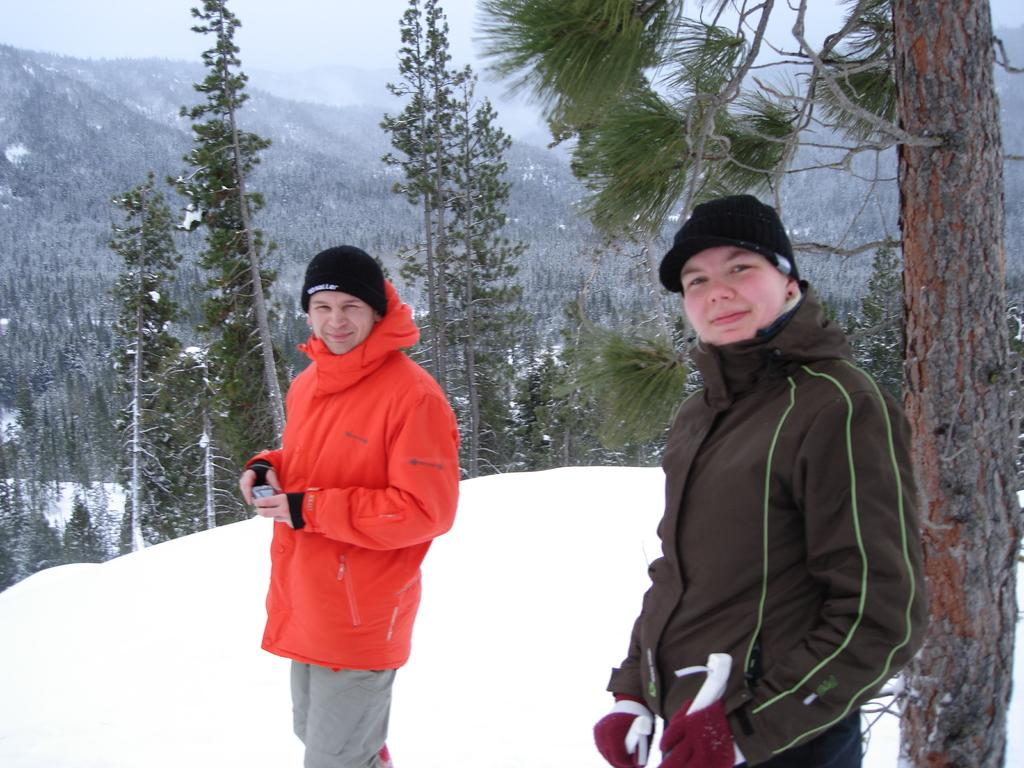What can be seen in the image regarding the people present? There are men standing in the image. What are the men wearing that might provide information about the weather or season? The men are wearing jackets. What type of terrain is visible in the image? There is ground covered with grass in the image. What additional natural elements can be seen in the image? There are trees in the image. How does the presence of snow on the trees indicate the current weather or season? The trees are covered with snow, which suggests that it is winter or a cold season. What time of day is it in the image, and how can you tell? The time of day cannot be determined from the image, as there are no clues such as shadows or a clock. What type of paint is being used by the trees in the image? There is no paint present in the image; the trees are covered with snow. 